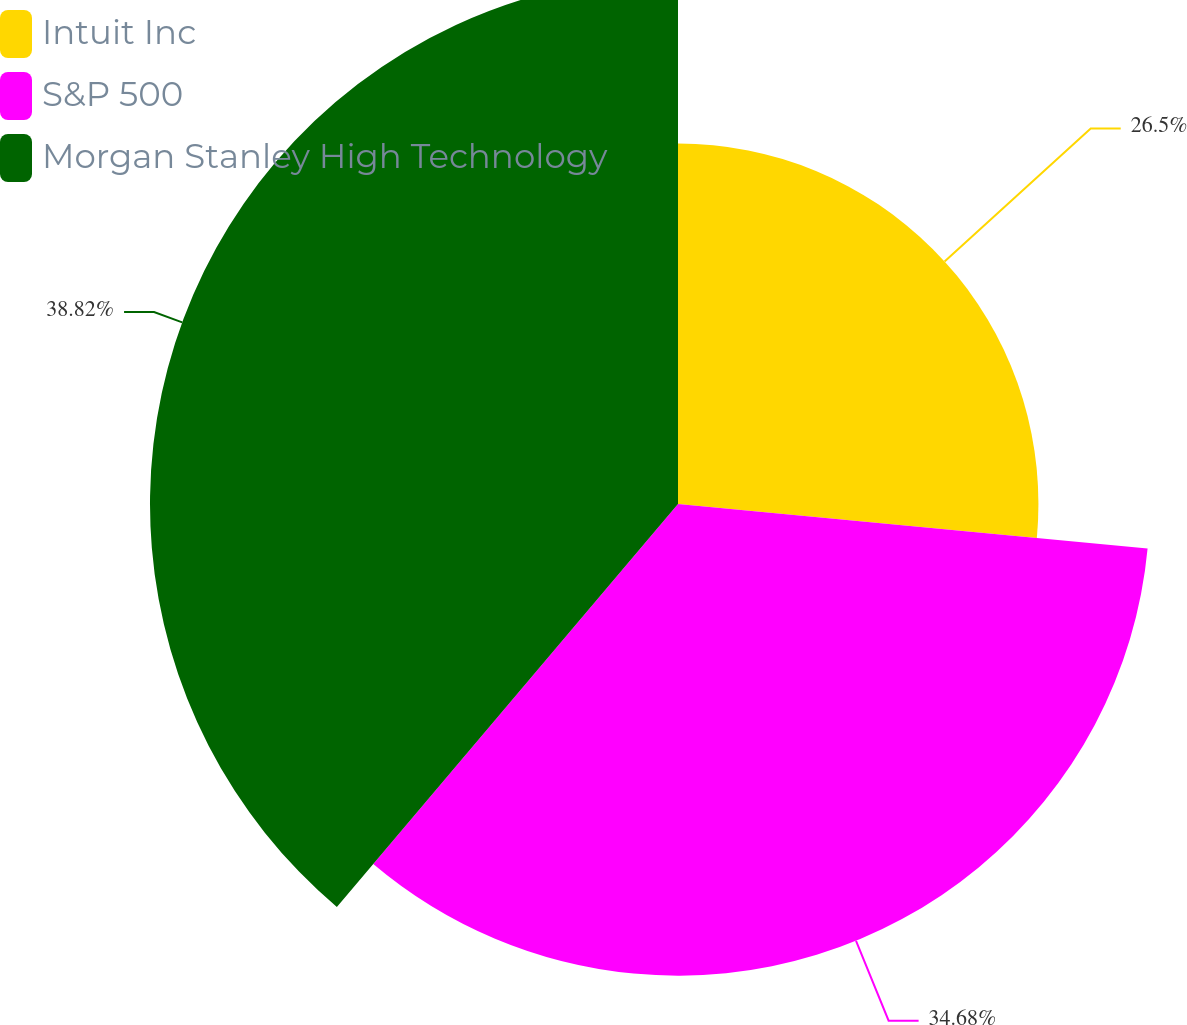Convert chart to OTSL. <chart><loc_0><loc_0><loc_500><loc_500><pie_chart><fcel>Intuit Inc<fcel>S&P 500<fcel>Morgan Stanley High Technology<nl><fcel>26.5%<fcel>34.68%<fcel>38.82%<nl></chart> 